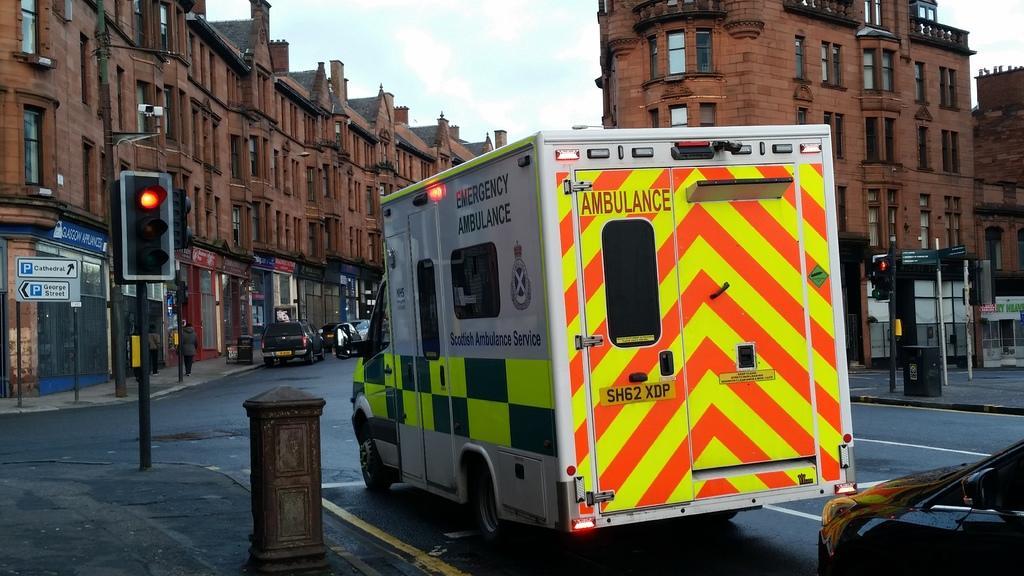Please provide a concise description of this image. In this image I can see there is an ambulance, car at the signal and there are a few poles with traffic lights. There are few buildings with windows and the sky is clear. 